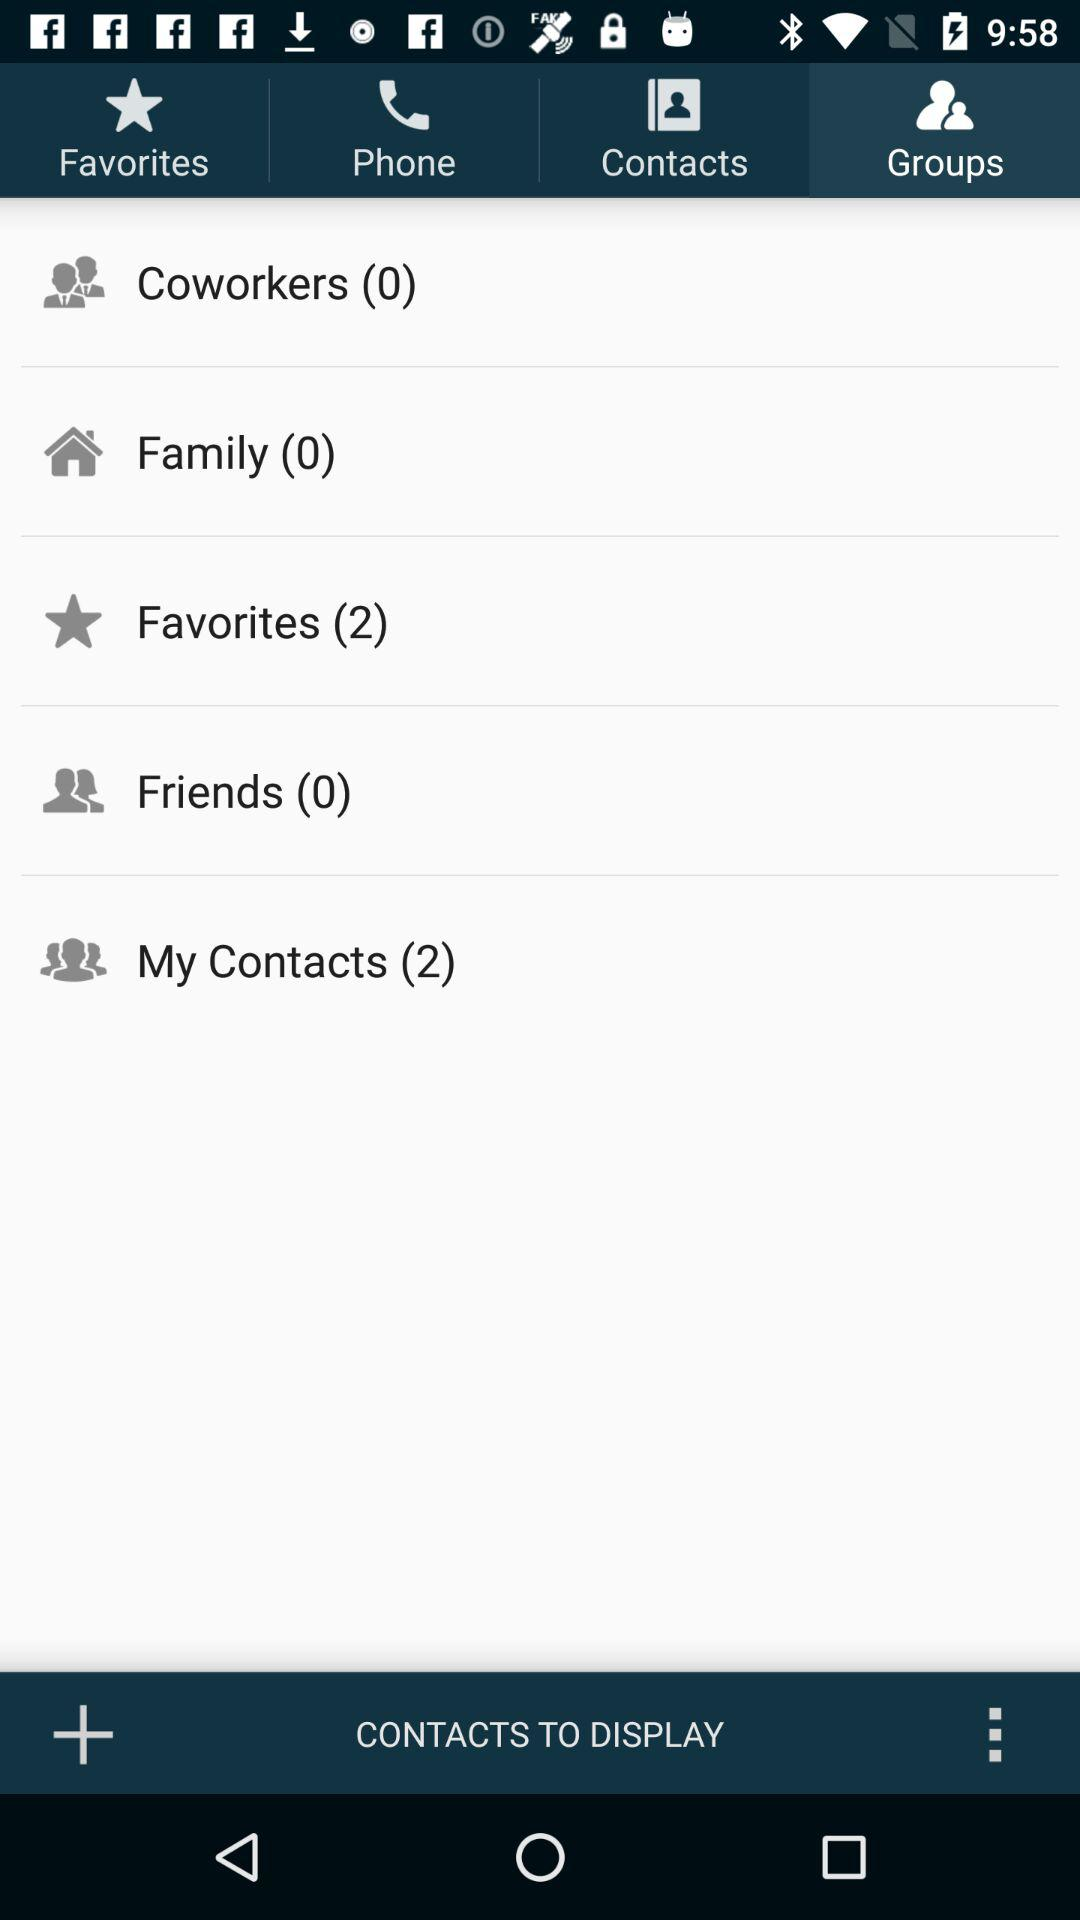How many contacts are in the Favorites group?
Answer the question using a single word or phrase. 2 